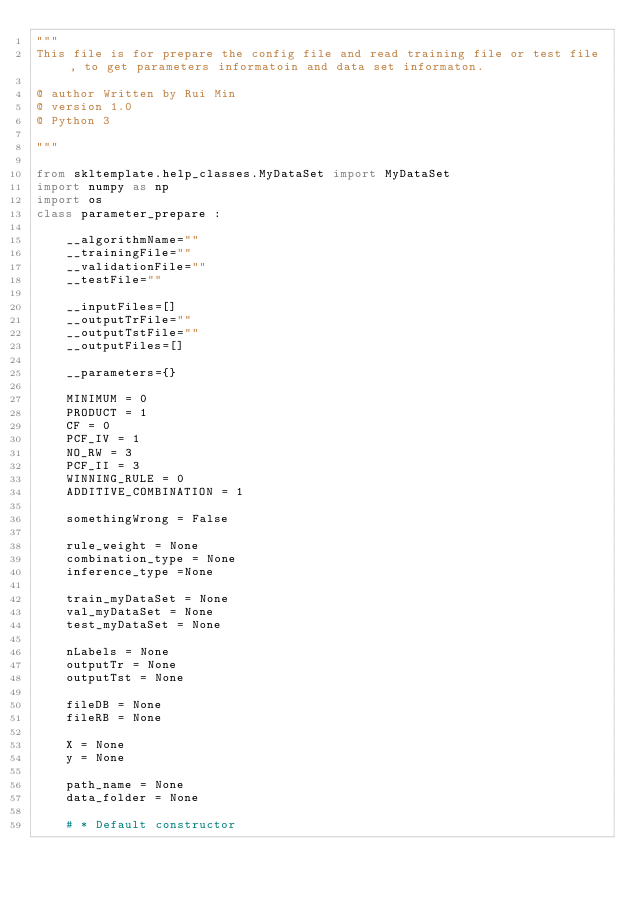<code> <loc_0><loc_0><loc_500><loc_500><_Python_>"""
This file is for prepare the config file and read training file or test file , to get parameters informatoin and data set informaton.

@ author Written by Rui Min
@ version 1.0
@ Python 3

"""

from skltemplate.help_classes.MyDataSet import MyDataSet
import numpy as np
import os
class parameter_prepare : 

    __algorithmName=""
    __trainingFile=""
    __validationFile=""
    __testFile=""

    __inputFiles=[]
    __outputTrFile=""
    __outputTstFile=""
    __outputFiles=[]

    __parameters={}

    MINIMUM = 0
    PRODUCT = 1
    CF = 0
    PCF_IV = 1
    NO_RW = 3
    PCF_II = 3
    WINNING_RULE = 0
    ADDITIVE_COMBINATION = 1

    somethingWrong = False 

    rule_weight = None
    combination_type = None
    inference_type =None

    train_myDataSet = None
    val_myDataSet = None
    test_myDataSet = None

    nLabels = None
    outputTr = None
    outputTst = None

    fileDB = None
    fileRB = None

    X = None
    y = None

    path_name = None
    data_folder = None

    # * Default constructor
</code> 